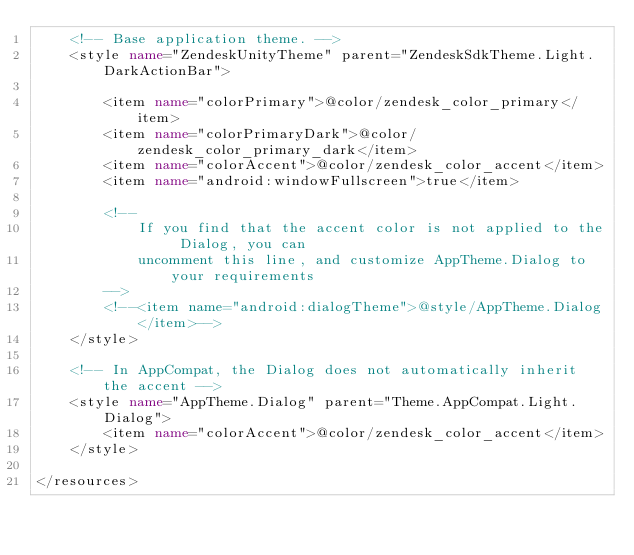<code> <loc_0><loc_0><loc_500><loc_500><_XML_>    <!-- Base application theme. -->
    <style name="ZendeskUnityTheme" parent="ZendeskSdkTheme.Light.DarkActionBar">

        <item name="colorPrimary">@color/zendesk_color_primary</item>
        <item name="colorPrimaryDark">@color/zendesk_color_primary_dark</item>
        <item name="colorAccent">@color/zendesk_color_accent</item>
        <item name="android:windowFullscreen">true</item>

        <!--
            If you find that the accent color is not applied to the Dialog, you can
            uncomment this line, and customize AppTheme.Dialog to your requirements
        -->
        <!--<item name="android:dialogTheme">@style/AppTheme.Dialog</item>-->
    </style>

    <!-- In AppCompat, the Dialog does not automatically inherit the accent -->
    <style name="AppTheme.Dialog" parent="Theme.AppCompat.Light.Dialog">
        <item name="colorAccent">@color/zendesk_color_accent</item>
    </style>

</resources>
</code> 